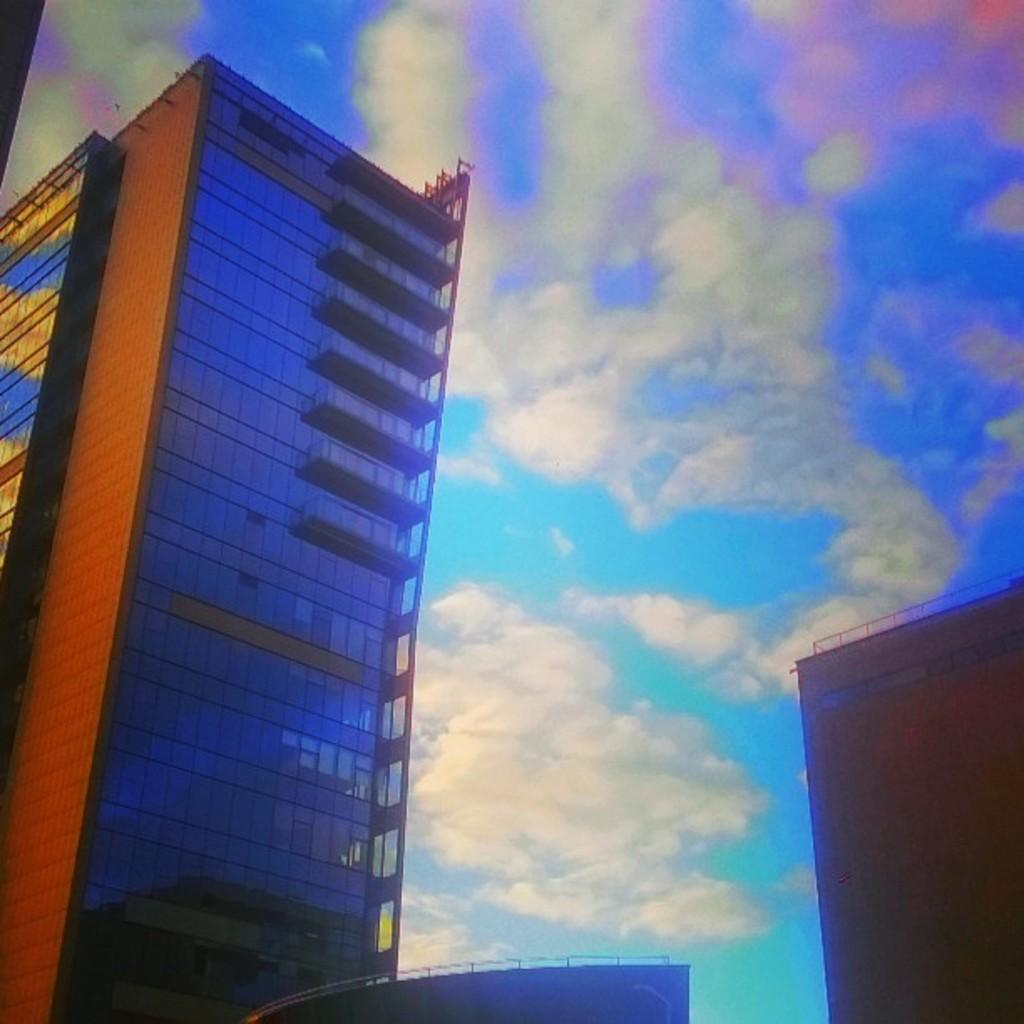What is the main subject of the image? The main subject of the image appears to be a screen displaying an image. What type of structures can be seen in the image? There are buildings visible in the image. What can be seen in the sky at the top of the image? There are clouds in the sky at the top of the image. What is the price of the fruit displayed on the screen in the image? There is no fruit displayed on the screen in the image, so it is not possible to determine the price. 